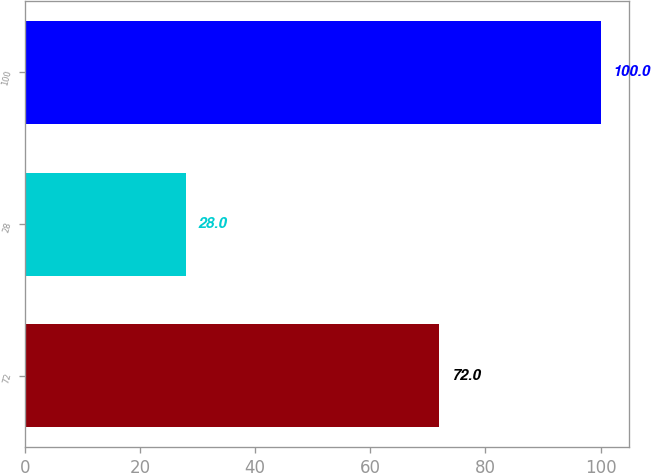Convert chart to OTSL. <chart><loc_0><loc_0><loc_500><loc_500><bar_chart><fcel>72<fcel>28<fcel>100<nl><fcel>72<fcel>28<fcel>100<nl></chart> 